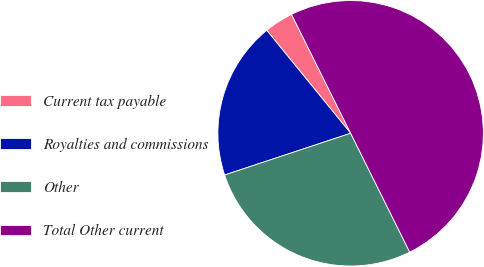Convert chart. <chart><loc_0><loc_0><loc_500><loc_500><pie_chart><fcel>Current tax payable<fcel>Royalties and commissions<fcel>Other<fcel>Total Other current<nl><fcel>3.54%<fcel>19.21%<fcel>27.25%<fcel>50.0%<nl></chart> 